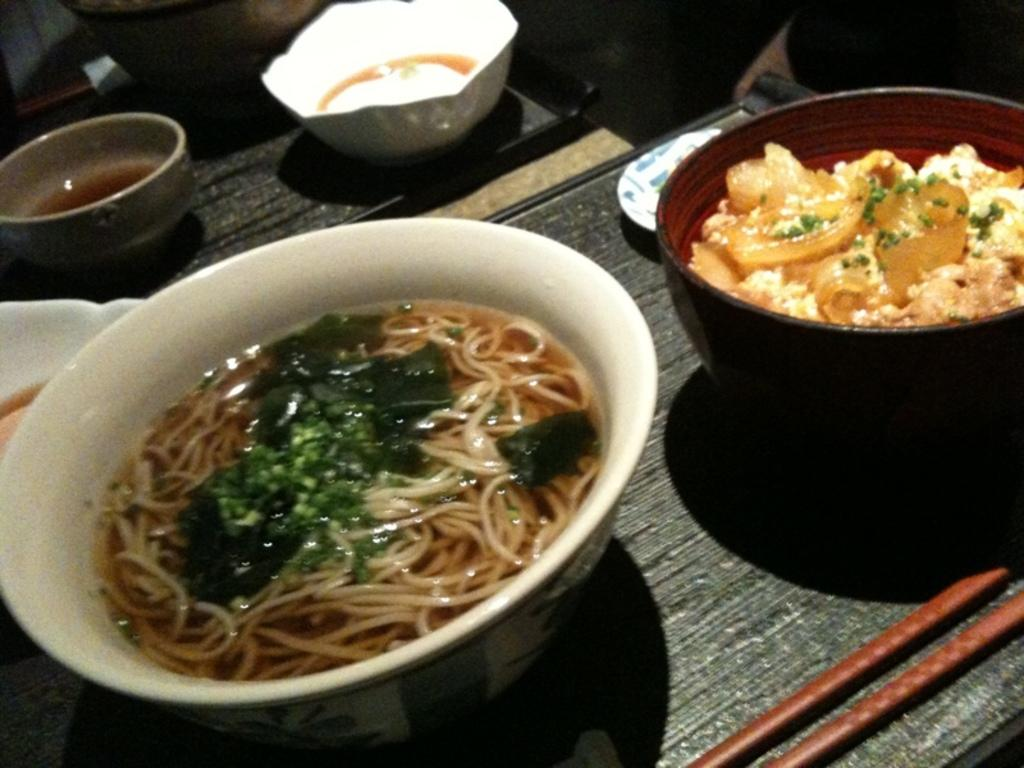What is the main piece of furniture in the image? There is a table in the image. What is placed on the table? There are bowls on the table. What is inside the bowls? The bowls contain food items, including noodles and soup. Are there any other food items in the bowls? Yes, there are other food items in the bowls. What color is the sky in the image? There is no sky visible in the image; it is set indoors. What type of brick is used to construct the table in the image? There is no information about the construction of the table in the image, and no bricks are visible. 